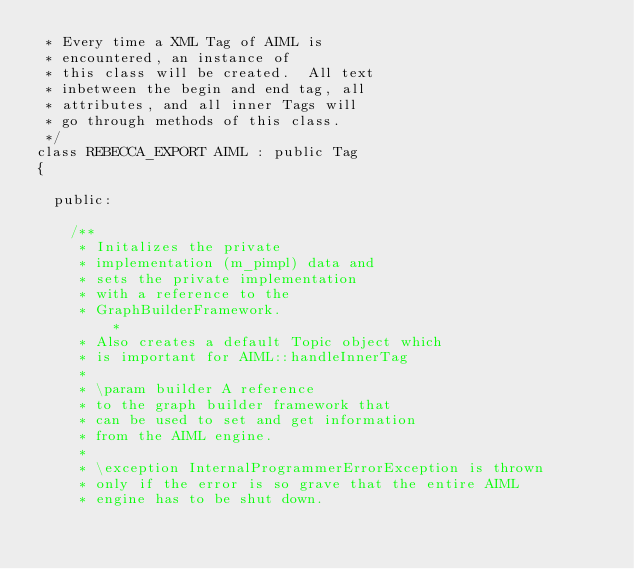<code> <loc_0><loc_0><loc_500><loc_500><_C_> * Every time a XML Tag of AIML is 
 * encountered, an instance of 
 * this class will be created.  All text
 * inbetween the begin and end tag, all
 * attributes, and all inner Tags will
 * go through methods of this class.
 */
class REBECCA_EXPORT AIML : public Tag
{
	
	public:

		/** 
		 * Initalizes the private 
		 * implementation (m_pimpl) data and 
		 * sets the private implementation 
		 * with a reference to the 
		 * GraphBuilderFramework.  
         *
		 * Also creates a default Topic object which 
		 * is important for AIML::handleInnerTag
		 *
		 * \param builder A reference 
		 * to the graph builder framework that 
		 * can be used to set and get information 
		 * from the AIML engine.
		 *
		 * \exception InternalProgrammerErrorException is thrown 
		 * only if the error is so grave that the entire AIML 
		 * engine has to be shut down.</code> 